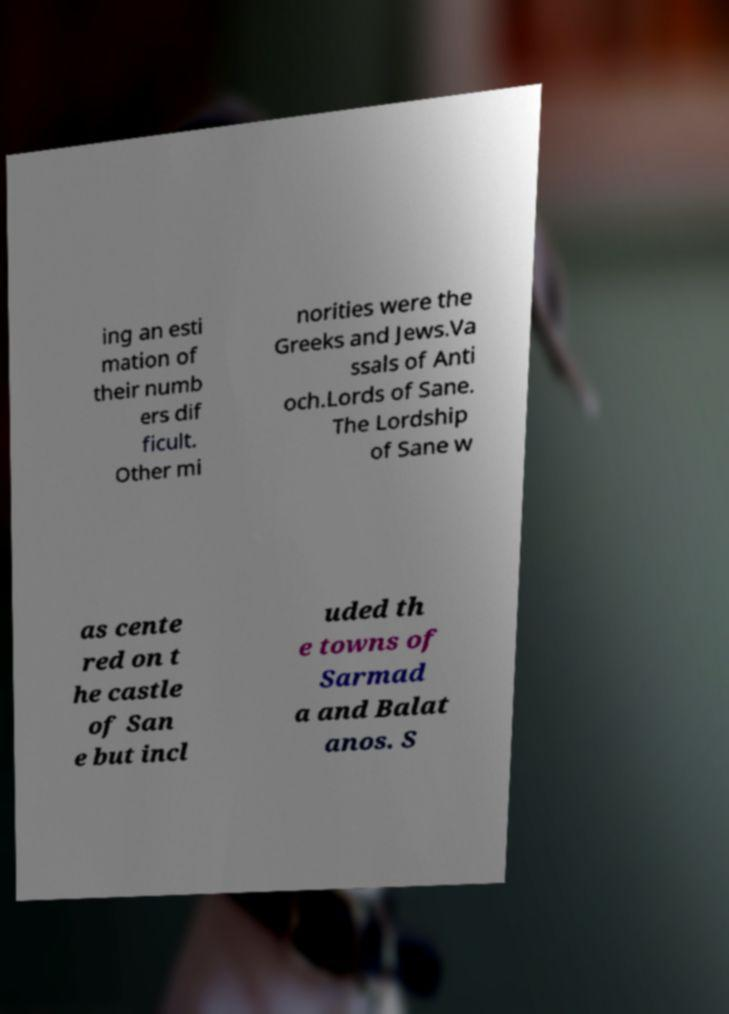Please identify and transcribe the text found in this image. ing an esti mation of their numb ers dif ficult. Other mi norities were the Greeks and Jews.Va ssals of Anti och.Lords of Sane. The Lordship of Sane w as cente red on t he castle of San e but incl uded th e towns of Sarmad a and Balat anos. S 